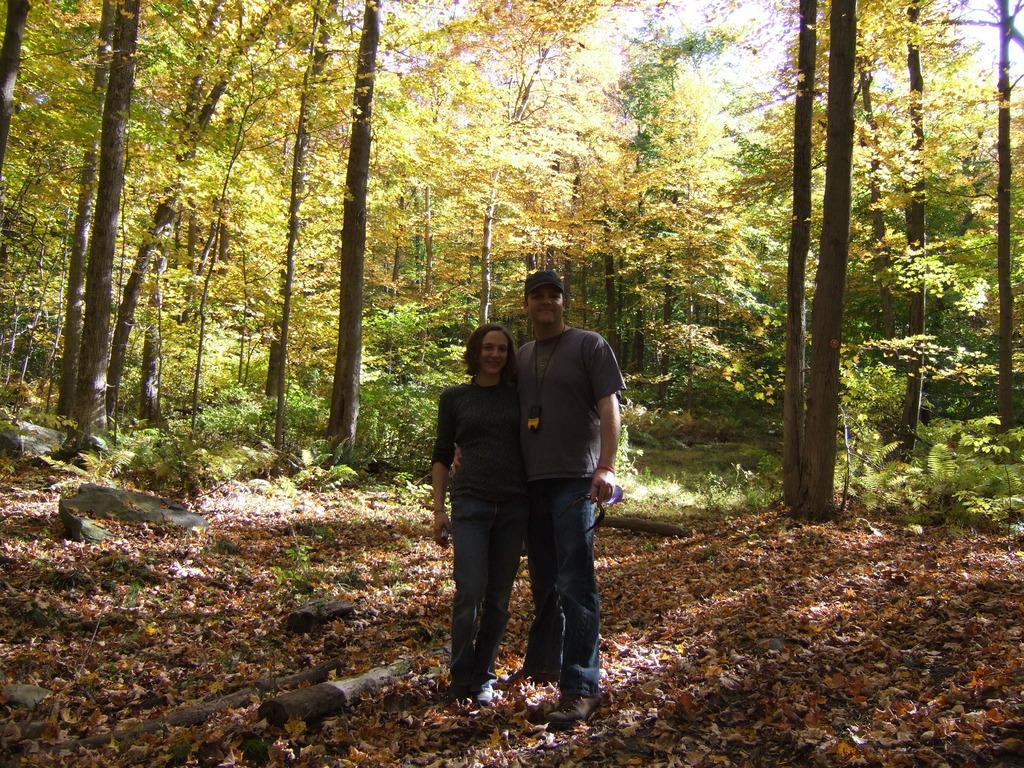How many people are present in the image? There are two people, a man and a woman, present in the image. What are the man and the woman doing in the image? Both the man and the woman are standing on the ground and smiling. What objects can be seen on the ground in the image? There are wooden logs and stones visible on the ground in the image. What can be seen in the background of the image? There are trees in the background of the image. What type of gold jewelry is the farmer wearing in the image? There is no farmer or gold jewelry present in the image. How does the image show an increase in the number of trees over time? The image does not show any changes over time, nor does it depict an increase in the number of trees. 